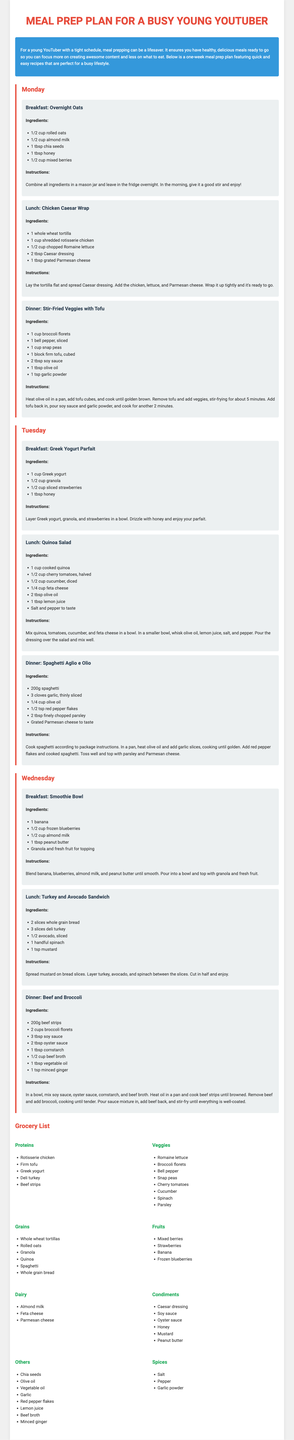What is the title of the document? The title of the document is provided at the top of the rendered HTML.
Answer: Meal Prep Plan for a Busy Young YouTuber How many days of meals are planned in the document? The document outlines meals for each day of the week, which amounts to seven days.
Answer: 7 What is the main focus of the meal prep plan? The document explicitly states its main purpose in the introduction.
Answer: Quick and easy recipes What is one ingredient used in Monday's breakfast? The specific ingredient is listed in the breakfast section of Monday's meals.
Answer: Rolled oats What is the cooking method used for the dinner on Tuesday? The cooking instructions detail the preparation method used for Tuesday's dinner.
Answer: Toss What type of yogurt is used in the Tuesday breakfast? The ingredient list for Tuesday's breakfast specifies the type of yogurt.
Answer: Greek yogurt Which meal features tofu? The dinner section on Monday lists the meal that includes tofu in its ingredients.
Answer: Stir-Fried Veggies with Tofu What is the grocery category that includes honey? The grocery list categorizes ingredients, and honey is listed under one of those categories.
Answer: Condiments How many different spices are listed in the document? The spices are specifically enumerated in the grocery list section.
Answer: 3 